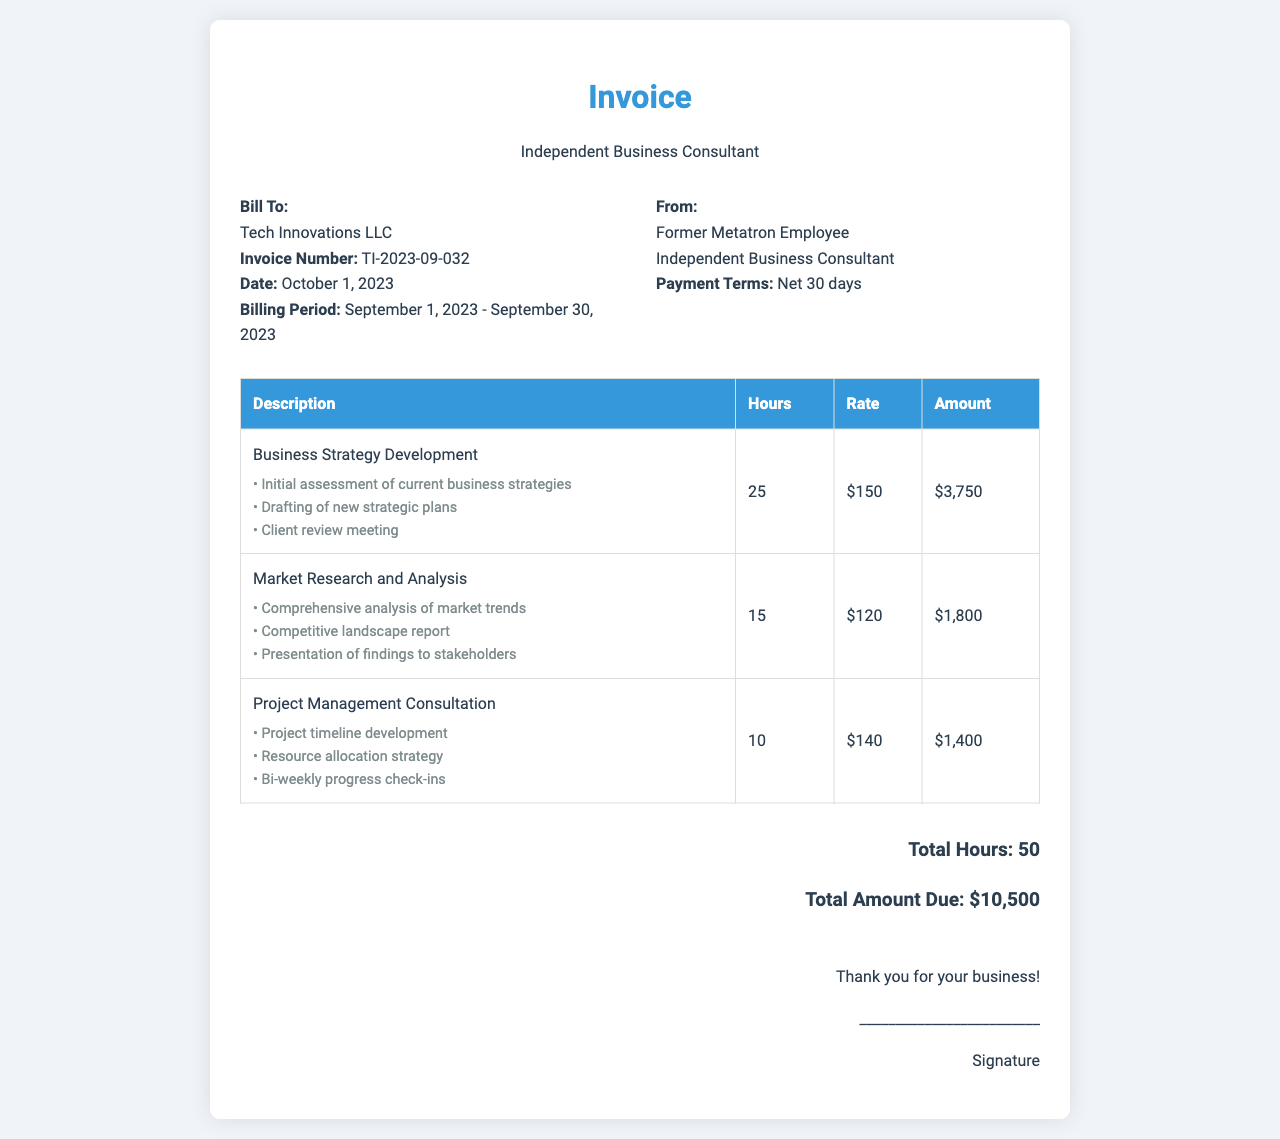What is the invoice number? The invoice number is specified in the invoice details, which is TI-2023-09-032.
Answer: TI-2023-09-032 What is the total amount due? The total amount due is provided at the bottom of the invoice, which is $10,500.
Answer: $10,500 What is the hourly rate for Business Strategy Development? The hourly rate for Business Strategy Development is listed in the table as $150.
Answer: $150 How many hours were billed for Market Research and Analysis? The hours billed for Market Research and Analysis can be found in the table, which states 15 hours.
Answer: 15 What was one of the milestones for Project Management Consultation? One of the milestones for Project Management Consultation is noted as "Project timeline development" in the document.
Answer: Project timeline development How long is the billing period? The billing period is described in the invoice details, covering from September 1, 2023, to September 30, 2023.
Answer: September 1, 2023 - September 30, 2023 Who is the biller? The biller is mentioned in the invoice details as "Former Metatron Employee."
Answer: Former Metatron Employee What was the total number of hours worked for all services? The total number of hours worked is summarized at the bottom of the invoice, which is 50 hours.
Answer: 50 